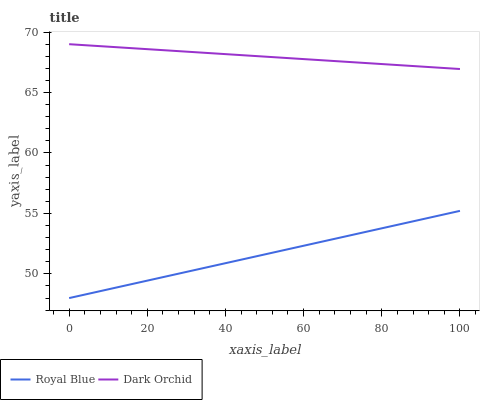Does Royal Blue have the minimum area under the curve?
Answer yes or no. Yes. Does Dark Orchid have the maximum area under the curve?
Answer yes or no. Yes. Does Dark Orchid have the minimum area under the curve?
Answer yes or no. No. Is Dark Orchid the smoothest?
Answer yes or no. Yes. Is Royal Blue the roughest?
Answer yes or no. Yes. Is Dark Orchid the roughest?
Answer yes or no. No. Does Royal Blue have the lowest value?
Answer yes or no. Yes. Does Dark Orchid have the lowest value?
Answer yes or no. No. Does Dark Orchid have the highest value?
Answer yes or no. Yes. Is Royal Blue less than Dark Orchid?
Answer yes or no. Yes. Is Dark Orchid greater than Royal Blue?
Answer yes or no. Yes. Does Royal Blue intersect Dark Orchid?
Answer yes or no. No. 